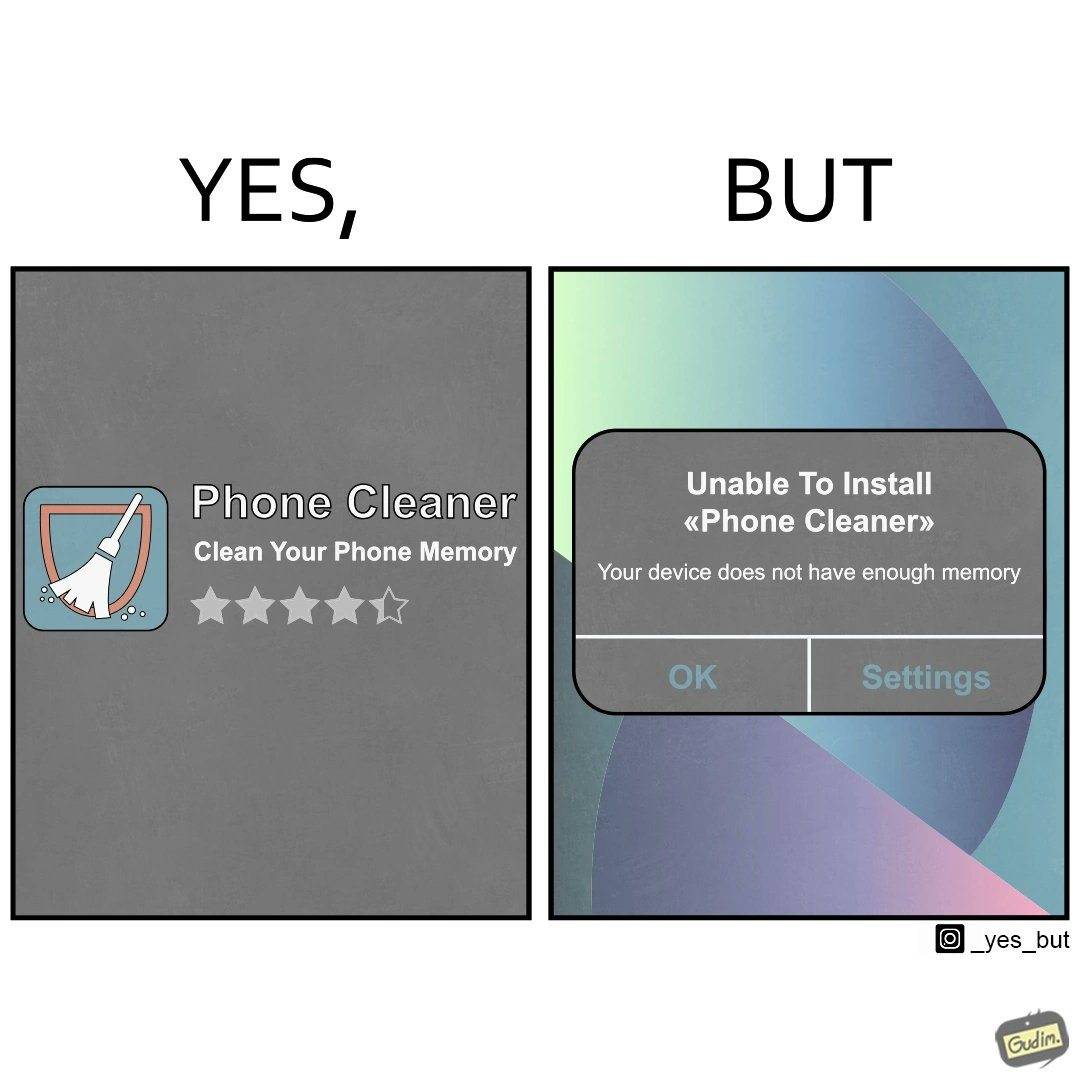What is shown in the left half versus the right half of this image? In the left part of the image: Phone cleaner app for cleaning phone memory, with a 4+ star rating. In the right part of the image: A pop-up message on a mobile device, showing that it is unable to install an app named "Phone cleaner" that due to insufficient availability of memory on the device. 